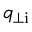<formula> <loc_0><loc_0><loc_500><loc_500>q _ { \perp i }</formula> 